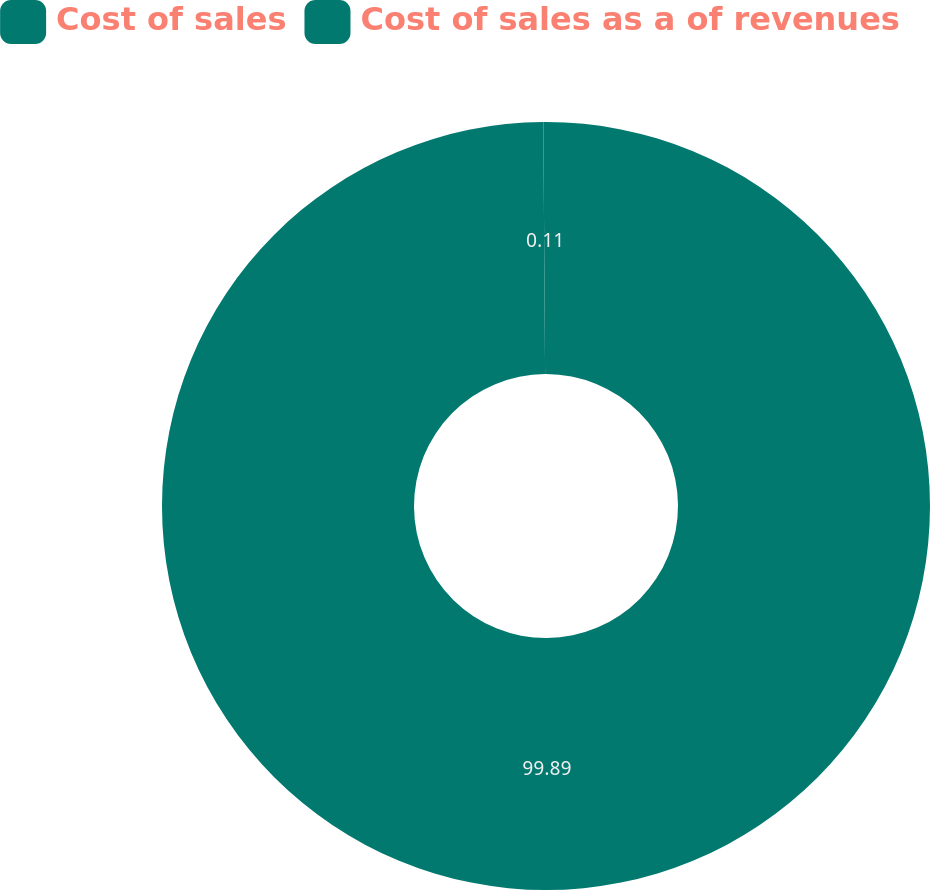Convert chart. <chart><loc_0><loc_0><loc_500><loc_500><pie_chart><fcel>Cost of sales<fcel>Cost of sales as a of revenues<nl><fcel>99.89%<fcel>0.11%<nl></chart> 